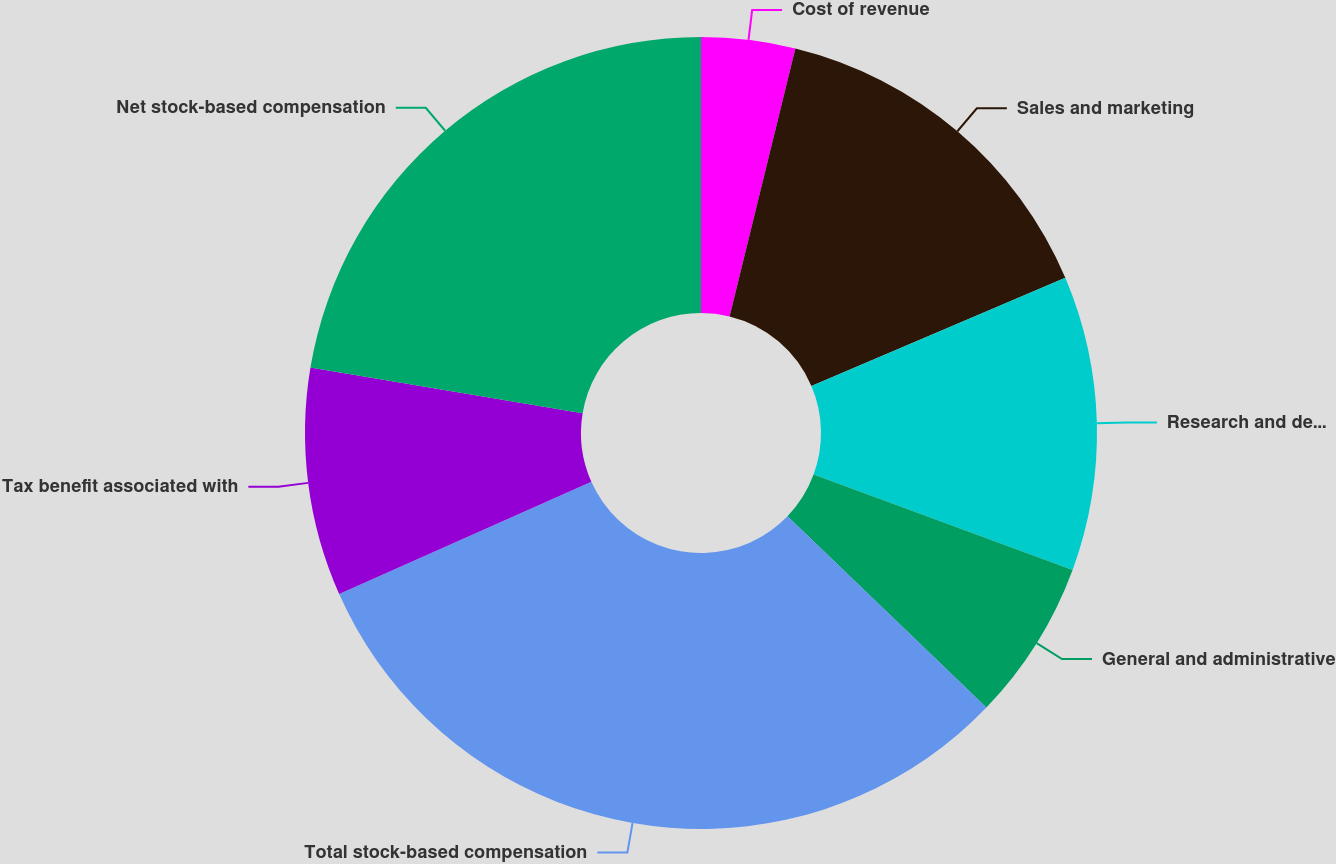Convert chart to OTSL. <chart><loc_0><loc_0><loc_500><loc_500><pie_chart><fcel>Cost of revenue<fcel>Sales and marketing<fcel>Research and development<fcel>General and administrative<fcel>Total stock-based compensation<fcel>Tax benefit associated with<fcel>Net stock-based compensation<nl><fcel>3.83%<fcel>14.76%<fcel>12.03%<fcel>6.57%<fcel>31.15%<fcel>9.3%<fcel>22.36%<nl></chart> 